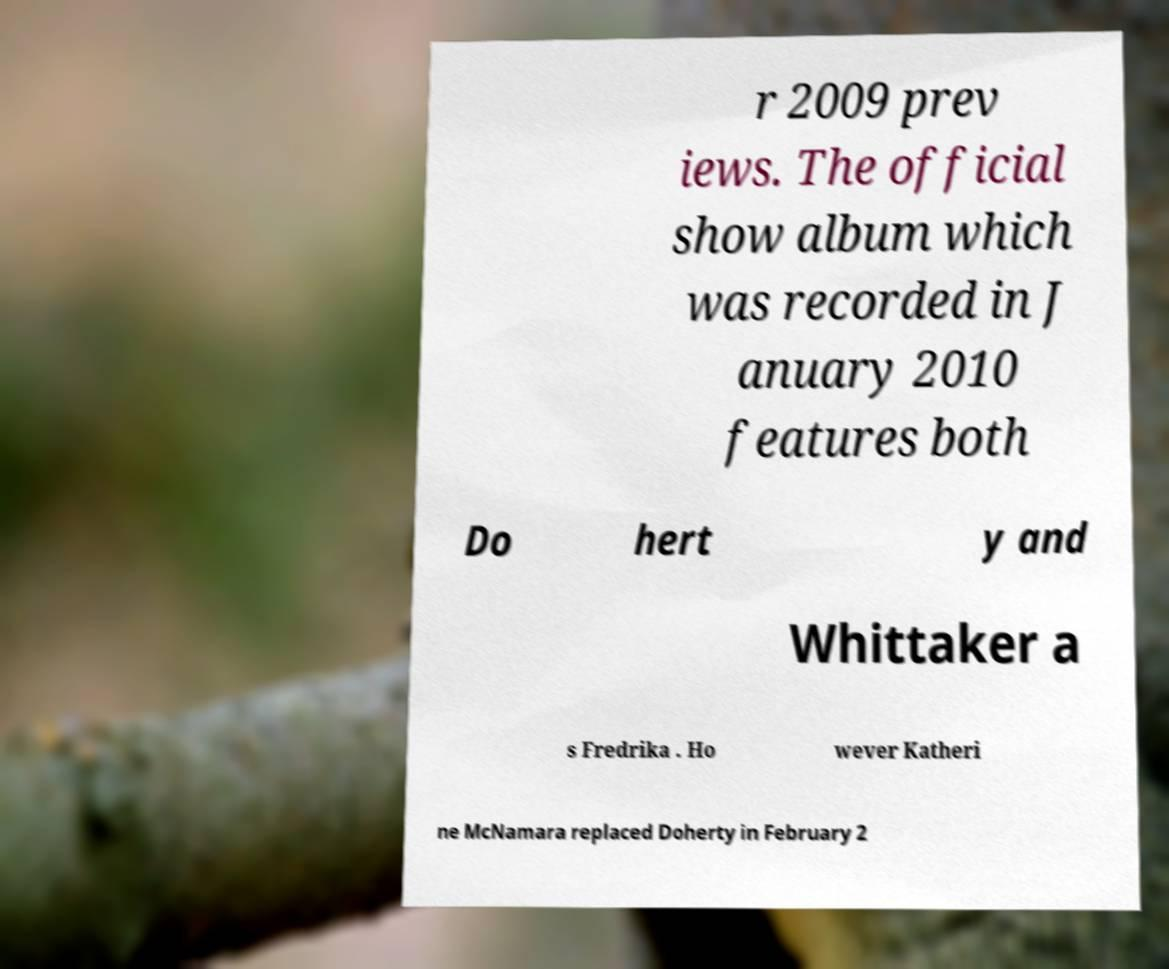Can you accurately transcribe the text from the provided image for me? r 2009 prev iews. The official show album which was recorded in J anuary 2010 features both Do hert y and Whittaker a s Fredrika . Ho wever Katheri ne McNamara replaced Doherty in February 2 